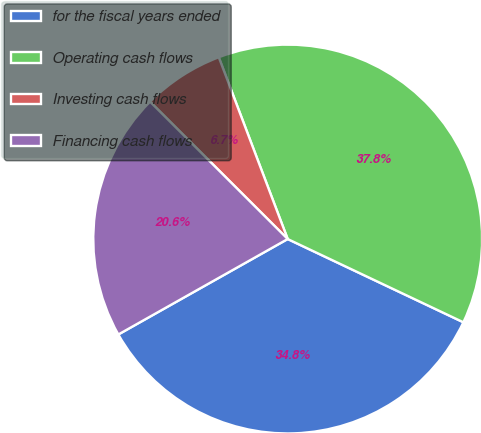Convert chart. <chart><loc_0><loc_0><loc_500><loc_500><pie_chart><fcel>for the fiscal years ended<fcel>Operating cash flows<fcel>Investing cash flows<fcel>Financing cash flows<nl><fcel>34.79%<fcel>37.81%<fcel>6.75%<fcel>20.65%<nl></chart> 